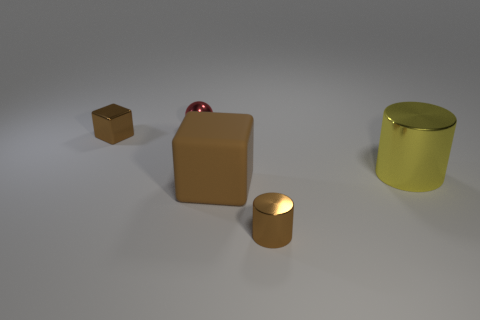Add 1 small blue matte balls. How many objects exist? 6 Subtract all cylinders. How many objects are left? 3 Add 3 big yellow shiny things. How many big yellow shiny things are left? 4 Add 2 small blue rubber blocks. How many small blue rubber blocks exist? 2 Subtract 1 brown cylinders. How many objects are left? 4 Subtract all brown rubber objects. Subtract all small metallic balls. How many objects are left? 3 